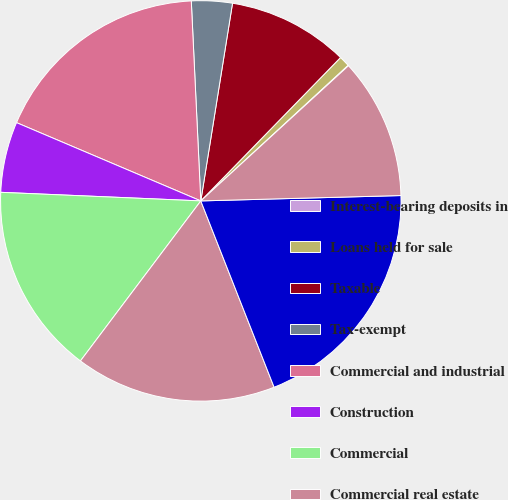Convert chart to OTSL. <chart><loc_0><loc_0><loc_500><loc_500><pie_chart><fcel>Interest-bearing deposits in<fcel>Loans held for sale<fcel>Taxable<fcel>Tax-exempt<fcel>Commercial and industrial<fcel>Construction<fcel>Commercial<fcel>Commercial real estate<fcel>Total commercial<fcel>Automobile loans and leases<nl><fcel>0.05%<fcel>0.86%<fcel>9.76%<fcel>3.29%<fcel>17.85%<fcel>5.71%<fcel>15.42%<fcel>16.23%<fcel>19.46%<fcel>11.37%<nl></chart> 